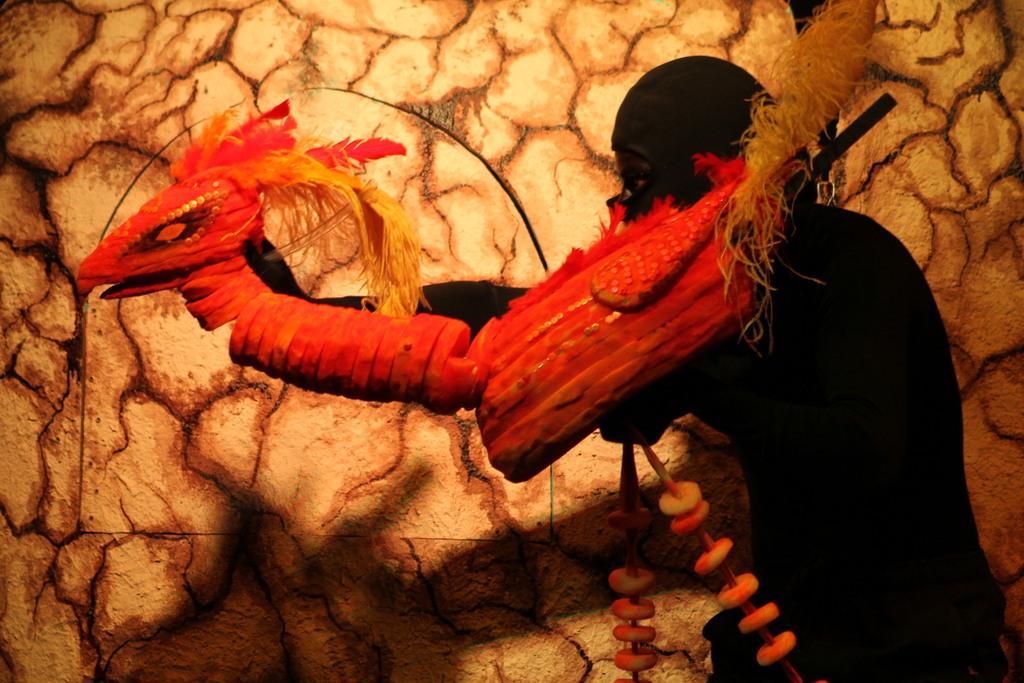Please provide a concise description of this image. This picture consists of illustration in the image. 